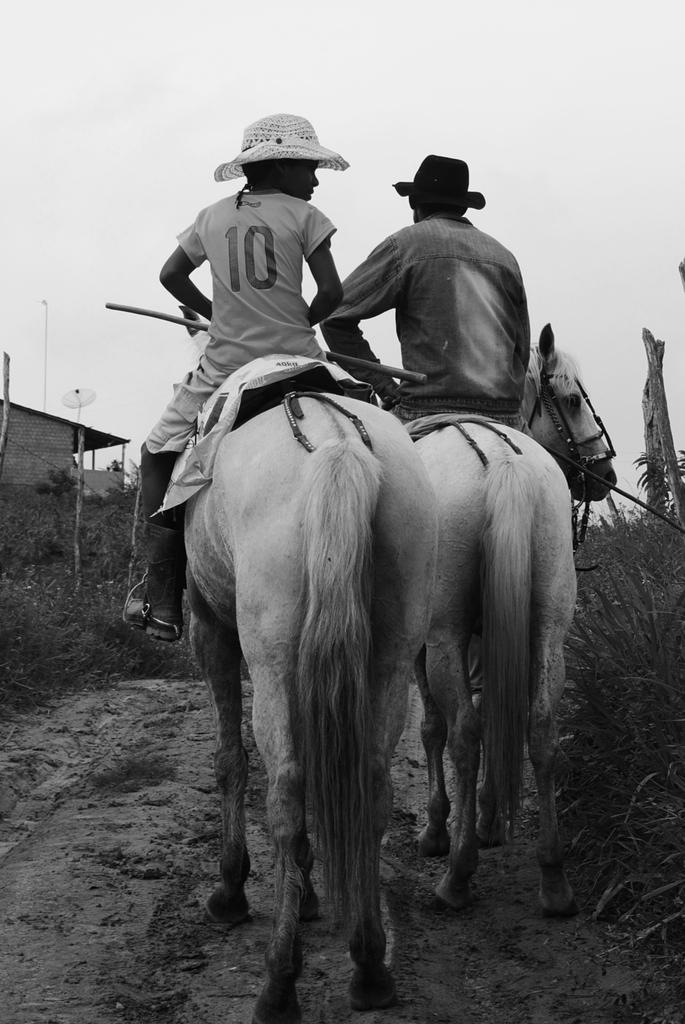What is the color scheme of the image? The image is black and white. How many horses are present in the image? There are two horses in the image. Who is riding the horses? There are two persons riding the horses. What type of vegetation can be seen in the image? There are small plants in the image. What structure is visible in the background of the image? There is a small house in the background of the image. What is the title of the book that the riders are reading in the image? There is no book or reading activity depicted in the image; it features two horses with riders and a small house in the background. 